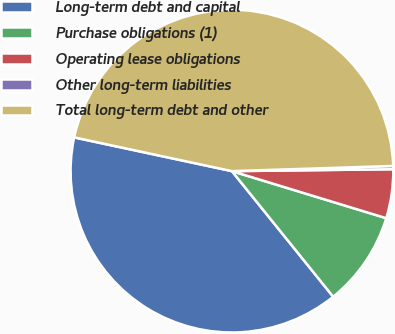<chart> <loc_0><loc_0><loc_500><loc_500><pie_chart><fcel>Long-term debt and capital<fcel>Purchase obligations (1)<fcel>Operating lease obligations<fcel>Other long-term liabilities<fcel>Total long-term debt and other<nl><fcel>39.15%<fcel>9.49%<fcel>4.9%<fcel>0.32%<fcel>46.13%<nl></chart> 